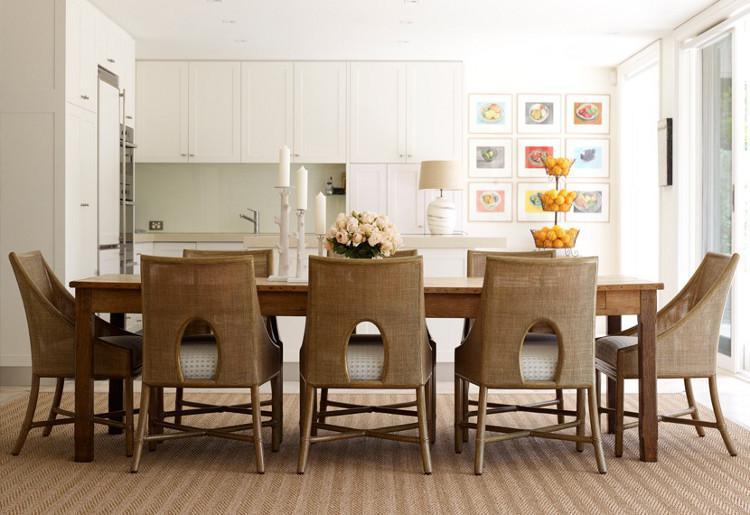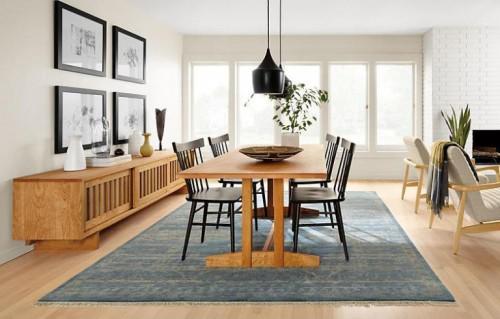The first image is the image on the left, the second image is the image on the right. Evaluate the accuracy of this statement regarding the images: "One long table is shown with four chairs and one with six chairs.". Is it true? Answer yes or no. No. 